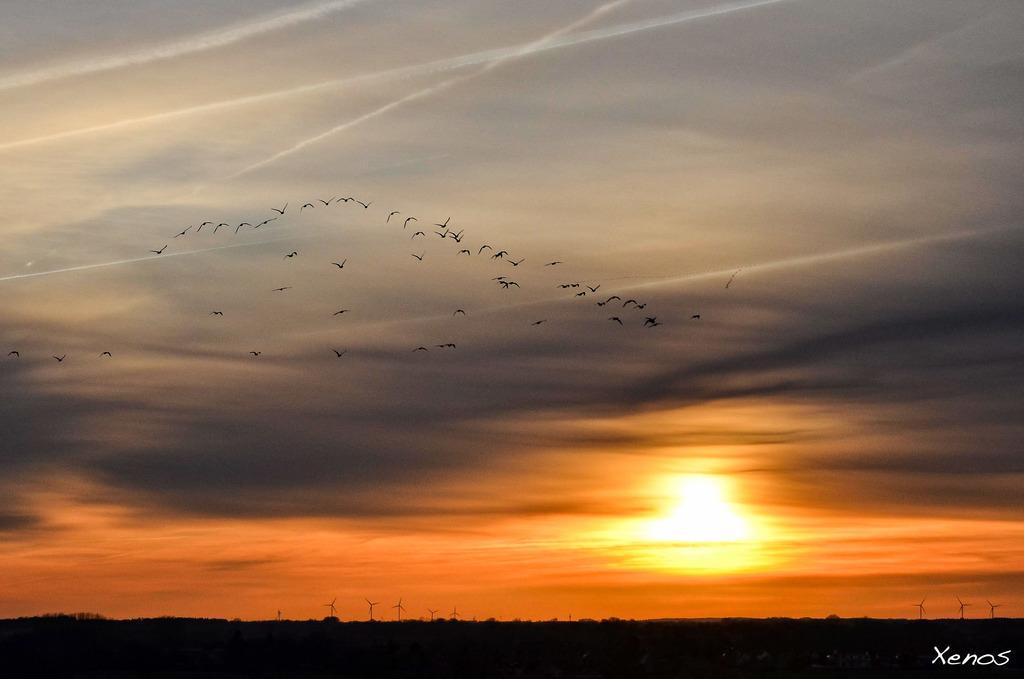Please provide a concise description of this image. At the bottom of the image we can see the sun and there are windmills. At the top there are birds and sky. 